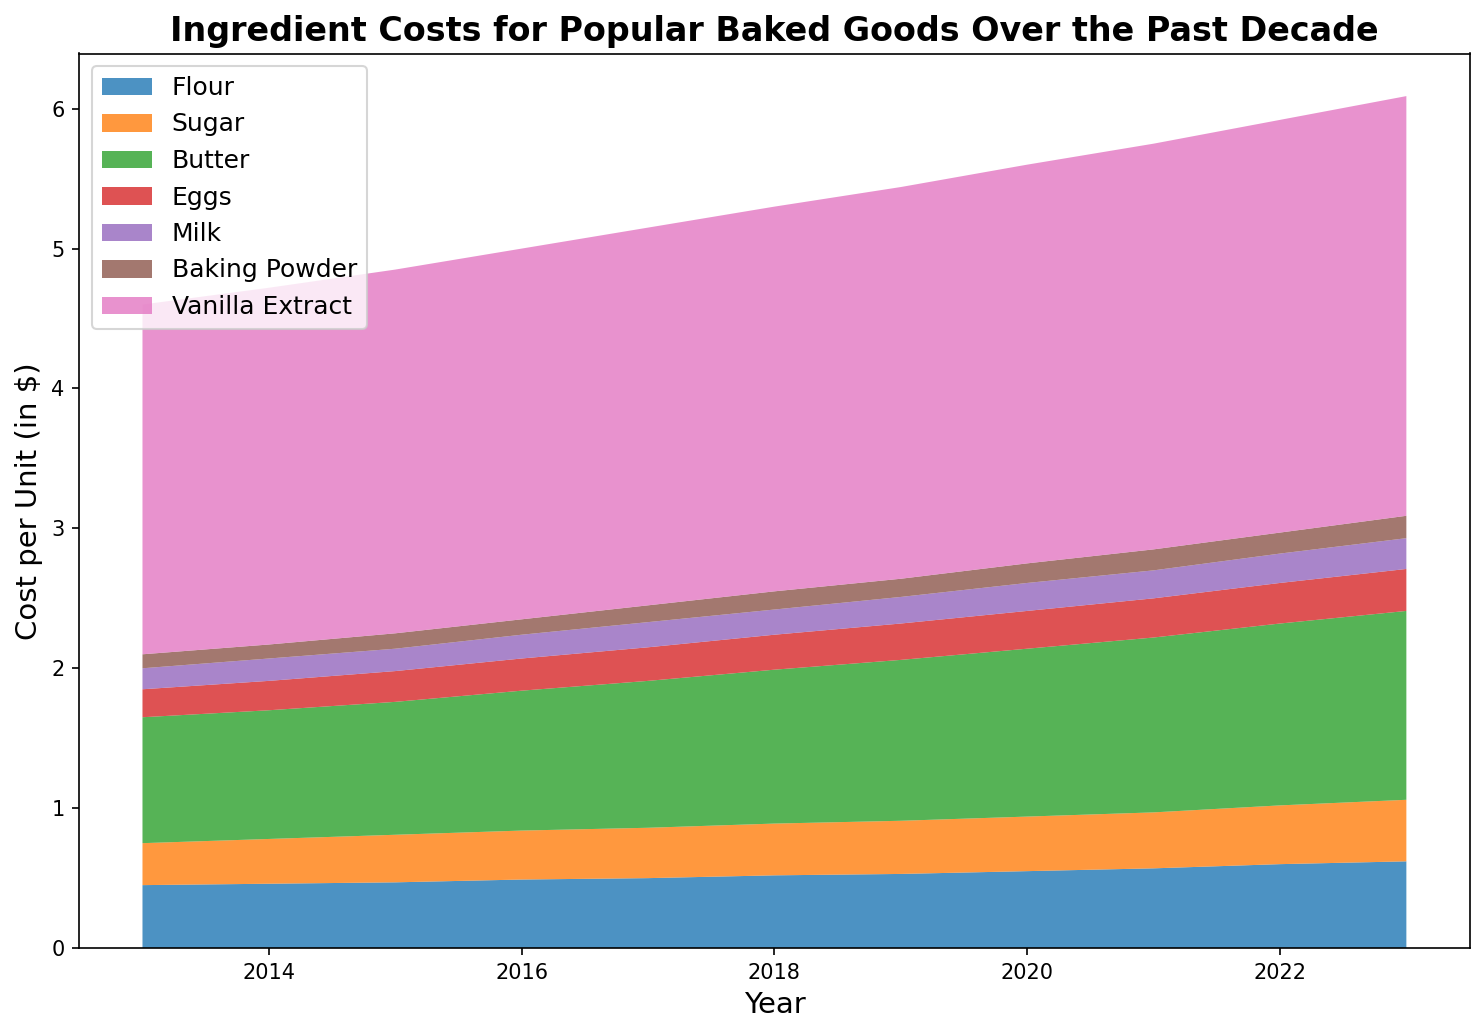What was the cost of Vanilla Extract in 2020? Look for the section of Vanilla Extract in the area chart and identify the value corresponding to the year 2020.
Answer: 2.85 Has the cost of Butter increased, decreased, or remained the same from 2013 to 2023? Compare the height of the Butter section on the graph for the years 2013 and 2023.
Answer: Increased Which ingredient shows the most consistent increase in cost over the decade? Look for the ingredient whose section consistently grows in height across all years in the chart.
Answer: Vanilla Extract Between 2015 and 2018, by how much did the cost of Eggs increase? Find the height of the Eggs section for 2015 and subtract it from the height in 2018.
Answer: 0.03 In which year was the cost of Milk at 0.20? Identify the year when the section for Milk reaches the height corresponding to 0.20.
Answer: 2020 Which ingredient had the highest cost per unit in 2013? Look for the ingredient with the largest section height in the year 2013.
Answer: Vanilla Extract How did the cost of Baking Powder change from 2016 to 2023? Compare the height of the Baking Powder section for 2016 and 2023.
Answer: Increased What is the total cost per unit of Flour, Sugar, and Butter combined in 2023? Add the heights of the Flour, Sugar, and Butter sections for 2023.
Answer: 2.41 Which year saw the highest total cost per unit for all ingredients combined? Compare the total height (sum of all ingredient sections) for each year and identify the tallest one.
Answer: 2023 By how much did the total ingredient cost increase from 2013 to 2023? Sum the heights of all sections for 2013 and compare to the sum for 2023.
Answer: 1.99 